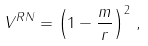Convert formula to latex. <formula><loc_0><loc_0><loc_500><loc_500>V ^ { R N } = \left ( 1 - \frac { m } { r } \right ) ^ { 2 } \, ,</formula> 